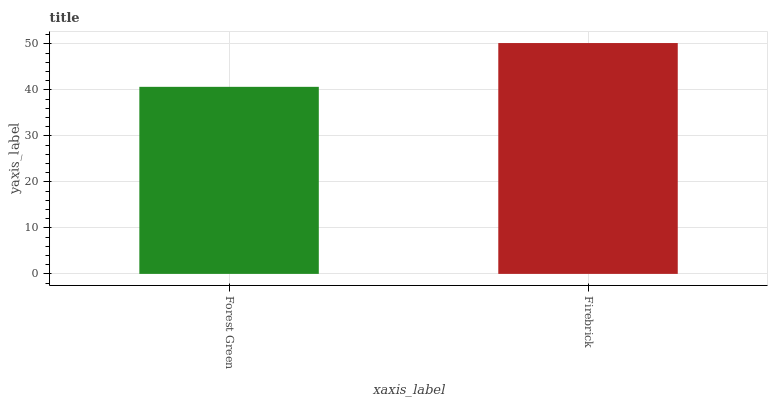Is Forest Green the minimum?
Answer yes or no. Yes. Is Firebrick the maximum?
Answer yes or no. Yes. Is Firebrick the minimum?
Answer yes or no. No. Is Firebrick greater than Forest Green?
Answer yes or no. Yes. Is Forest Green less than Firebrick?
Answer yes or no. Yes. Is Forest Green greater than Firebrick?
Answer yes or no. No. Is Firebrick less than Forest Green?
Answer yes or no. No. Is Firebrick the high median?
Answer yes or no. Yes. Is Forest Green the low median?
Answer yes or no. Yes. Is Forest Green the high median?
Answer yes or no. No. Is Firebrick the low median?
Answer yes or no. No. 